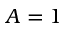<formula> <loc_0><loc_0><loc_500><loc_500>A = 1</formula> 